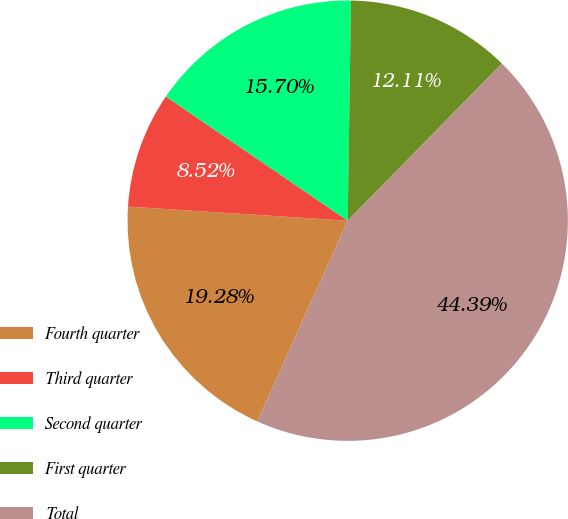Convert chart. <chart><loc_0><loc_0><loc_500><loc_500><pie_chart><fcel>Fourth quarter<fcel>Third quarter<fcel>Second quarter<fcel>First quarter<fcel>Total<nl><fcel>19.28%<fcel>8.52%<fcel>15.7%<fcel>12.11%<fcel>44.39%<nl></chart> 